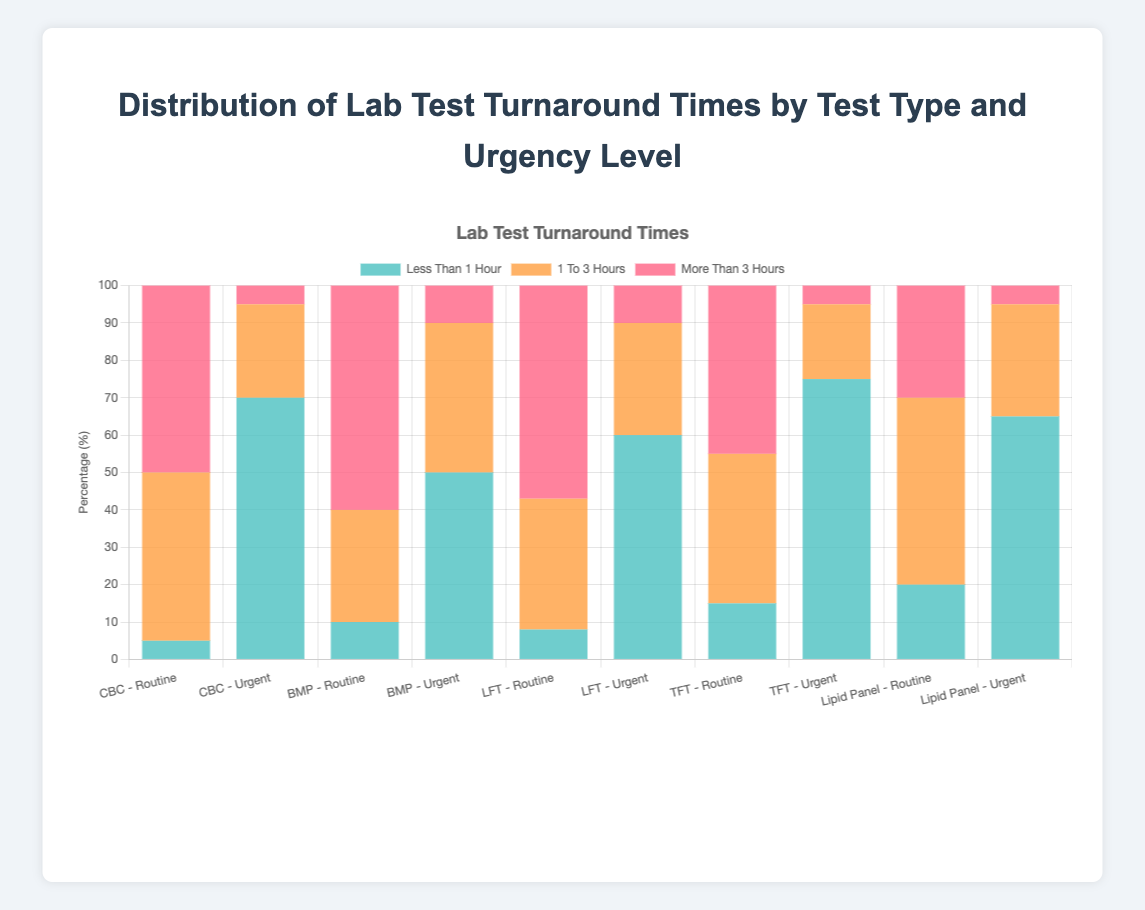How does the turnaround time for routine CBC tests compare to urgent CBC tests in terms of the 'Less Than 1 Hour' category? The bar corresponding to urgent CBC tests (70) is much taller than the bar for routine CBC tests (5). This indicates a higher percentage of urgent CBC tests are completed in less than 1 hour compared to routine CBC tests.
Answer: Urgent CBC tests have a higher percent Which test type and urgency level have the highest percentage of tests completed in '1 To 3 Hours'? Among all test types and urgency levels, the lipid panel with routine urgency has the highest percentage bar in the '1 To 3 Hours' category, measuring 50%.
Answer: Lipid Panel - Routine For Liver Function Test (LFT), which turnaround time category has the lowest percentage for both urgency levels? For both routine and urgent LFTs, the 'Less Than 1 Hour' category has the smallest bars, with percentages of 8 for routine and 60 for urgent.
Answer: Less Than 1 Hour What's the average percentage of 'More Than 3 Hours' turnaround times for all routine tests? The values for 'More Than 3 Hours' in routine tests are CBC (50), BMP (60), LFT (57), TFT (45), and Lipid Panel (30). Sum these (50 + 60 + 57 + 45 + 30) to get 242 and divide by 5 to get the average 242/5 = 48.4%.
Answer: 48.4% How does the percentage of '1 To 3 Hours' turnaround times for urgent BMP compare to routine BMP? The bar for '1 To 3 Hours' in urgent BMP (40) is taller than that in routine BMP (30), indicating a higher percentage of urgent BMP tests fall into this category.
Answer: Urgent BMP is higher Which urgency level for thyroid function tests (TFT) shows a higher percentage for 'More Than 3 Hours' completion time? The bar for 'More Than 3 Hours' is significantly higher in routine TFTs (45) compared to urgent TFTs (5).
Answer: Routine What is the total percentage of urgent tests completed in 'Less Than 1 Hour' across all test types? Sum the 'Less Than 1 Hour' values for all urgent tests: CBC (70) + BMP (50) + LFT (60) + TFT (75) + Lipid Panel (65). Therefore, the total is 70 + 50 + 60 + 75 + 65 = 320.
Answer: 320 Which test and urgency combination has the largest percentage of tests completed in 'More Than 3 Hours'? Among all test types and urgencies, the BMP with routine urgency displays the highest bar in the 'More Than 3 Hours' category, measuring 60%.
Answer: BMP - Routine Are routine or urgent tests generally completed faster for liver function tests (LFT)? Routine LFT tests have a higher percentage of 'More Than 3 Hours' (57) compared to urgent LFTs (10), whereas urgent LFTs have higher percentages in 'Less Than 1 Hour' and '1 To 3 Hours', indicating that urgent tests are generally completed faster.
Answer: Urgent tests Among all categories, which test type, and urgency level has the least percentage of tests completed in 'Less Than 1 Hour'? The category with the smallest bar in 'Less Than 1 Hour' is routine CBC, with 5%.
Answer: CBC - Routine 